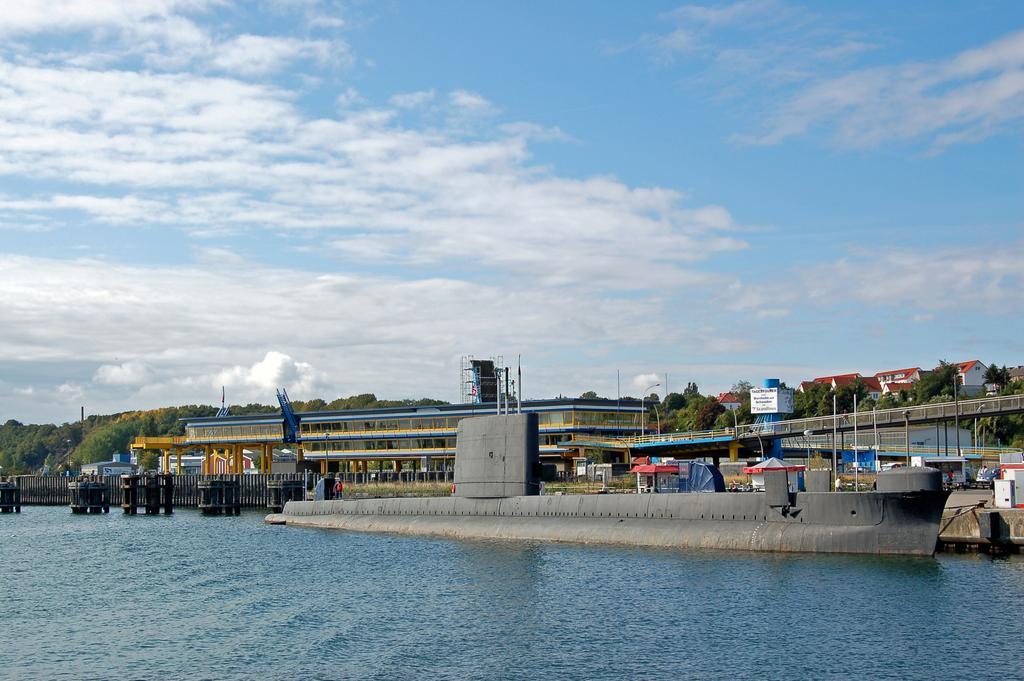Describe this image in one or two sentences. In the center of the image we can see buildings, street lights, pillars, trees, ship, sky and clouds. At the bottom of the image there is water. 